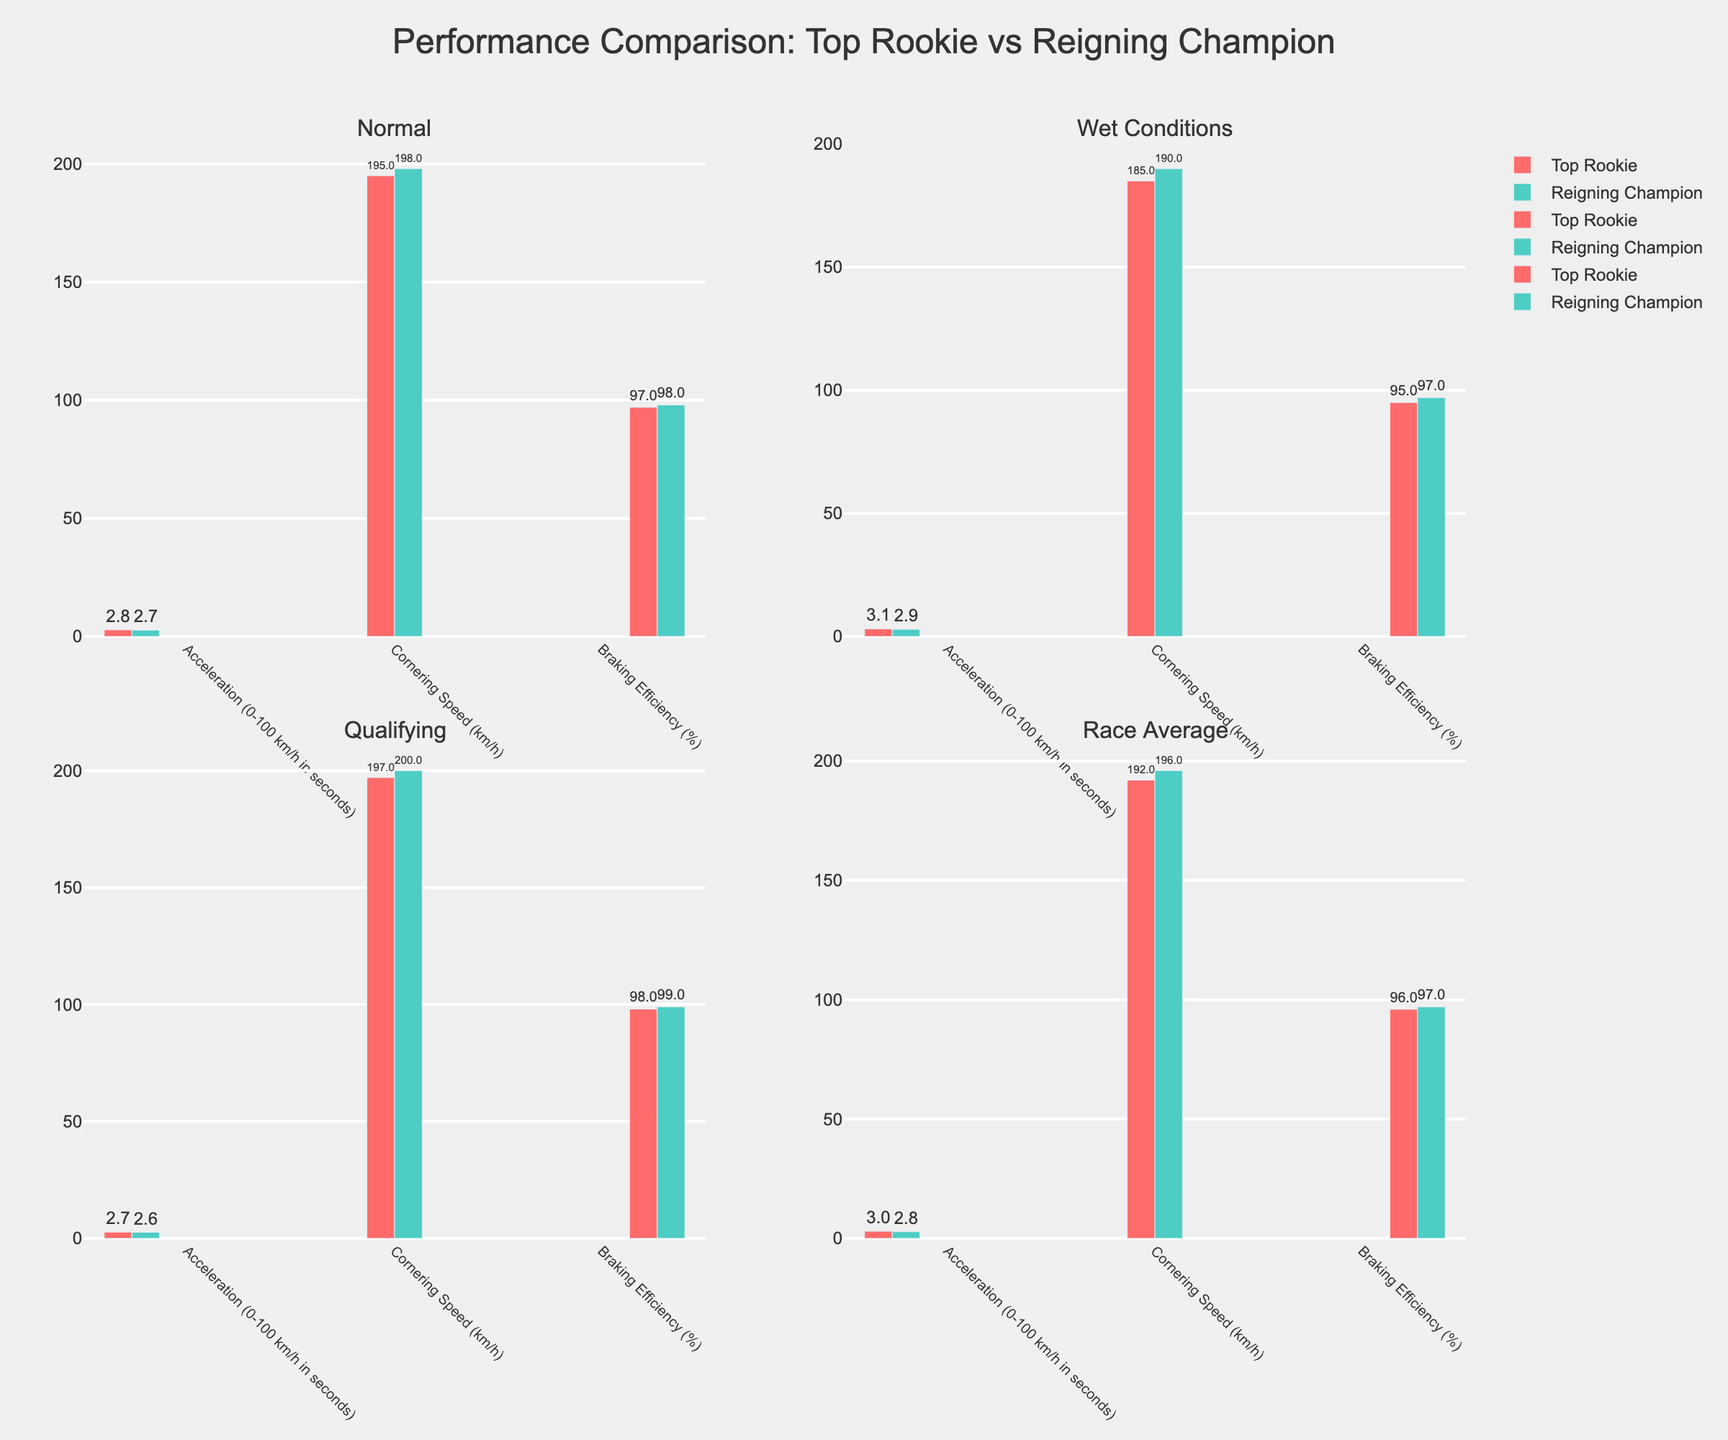What's the difference in acceleration between the Top Rookie and Reigning Champion under normal conditions? Observe the acceleration value for both drivers under normal conditions. The Top Rookie's acceleration is 2.8 seconds, and the Reigning Champion's is 2.7 seconds. The difference is 2.8 - 2.7 = 0.1 seconds.
Answer: 0.1 seconds Which driver has a higher cornering speed in qualifying conditions? Compare the cornering speeds in the qualifying conditions subplot. The Top Rookie has a cornering speed of 197 km/h, while the Reigning Champion has 200 km/h. The Reigning Champion has a higher cornering speed.
Answer: Reigning Champion What's the average braking efficiency of the Top Rookie across all conditions? Add the braking efficiencies for all conditions then divide by the number of conditions. For the Top Rookie: (97 + 95 + 98 + 96) / 4 = 386 / 4 = 96.5%.
Answer: 96.5% How much faster is the Reigning Champion's average race speed compared to the Top Rookie's average race speed? Check the cornering speed during the race average. The Top Rookie's value is 192 km/h, and the Reigning Champion's is 196 km/h. The difference is 196 - 192 = 4 km/h.
Answer: 4 km/h Does the Reigning Champion excel in all metrics under wet conditions compared to the Top Rookie? Compare the metrics one by one in the wet conditions subplot. Acceleration: 2.9 (Champion) vs 3.1 (Rookie), Cornering Speed: 190 vs 185, Braking Efficiency: 97% vs 95%. The Reigning Champion has better performance in all metrics.
Answer: Yes Which condition shows the largest gap in braking efficiency between the two drivers? Compare the differences in braking efficiency for each condition. The gaps are as follows: Normal: 98% - 97% = 1%, Wet: 97% - 95% = 2%, Qualifying: 99% - 98% = 1%, Race Average: 97% - 96% = 1%. The largest gap is during wet conditions with a gap of 2%.
Answer: Wet Conditions Under which condition do both drivers have the closest acceleration times? Assess the acceleration times across all subplots. For Normal: 2.8 vs 2.7 (0.1), Wet: 3.1 vs 2.9 (0.2), Qualifying: 2.7 vs 2.6 (0.1), Race Average: 3.0 vs 2.8 (0.2). The closest times are in Normal and Qualifying conditions with a gap of 0.1 seconds.
Answer: Normal and Qualifying 